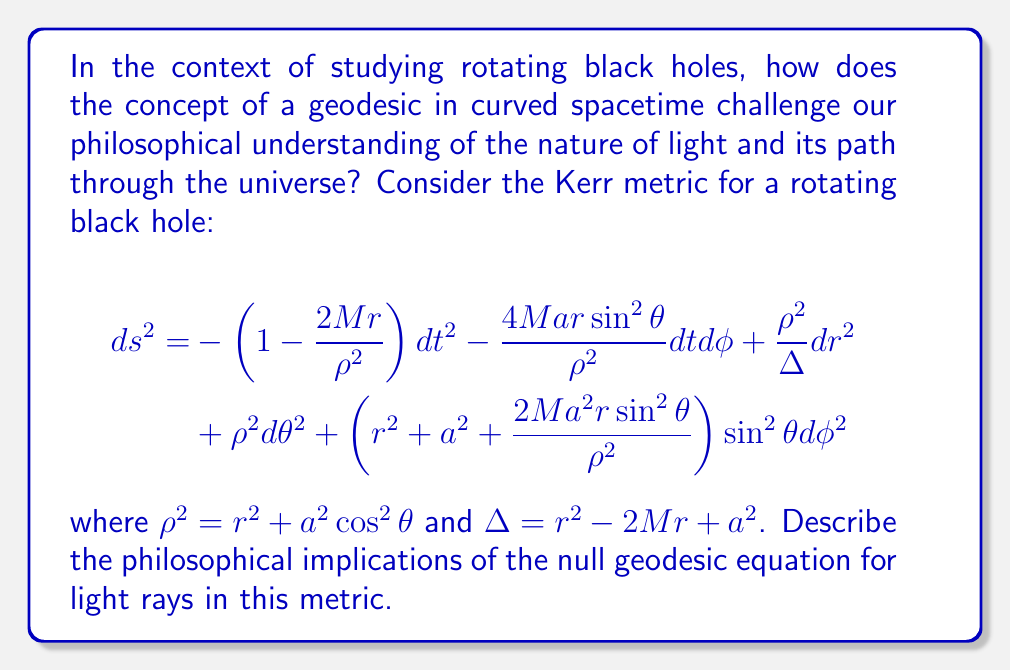Could you help me with this problem? To understand the philosophical implications of geodesics in curved spacetime around a rotating black hole, we need to examine the null geodesic equation in the Kerr metric:

1. The null geodesic equation is derived from the Lagrangian:
   $$\mathcal{L} = \frac{1}{2}g_{\mu\nu}\frac{dx^\mu}{d\lambda}\frac{dx^\nu}{d\lambda}$$
   where $\lambda$ is an affine parameter.

2. For light rays, we set $ds^2 = 0$ in the Kerr metric, as light follows null geodesics.

3. The geodesic equations are obtained using the Euler-Lagrange equations:
   $$\frac{d}{d\lambda}\left(\frac{\partial \mathcal{L}}{\partial \dot{x}^\mu}\right) - \frac{\partial \mathcal{L}}{\partial x^\mu} = 0$$

4. Due to the symmetries in the Kerr metric, we have two conserved quantities:
   - Energy: $E = -p_t = -g_{tt}\dot{t} - g_{t\phi}\dot{\phi}$
   - Angular momentum: $L = p_\phi = g_{\phi t}\dot{t} + g_{\phi\phi}\dot{\phi}$

5. The radial equation of motion can be written as:
   $$\left(\frac{dr}{d\lambda}\right)^2 = R(r)$$
   where $R(r)$ is a polynomial in $r$ that depends on $E$, $L$, and the black hole parameters.

6. The angular equation of motion is:
   $$\left(\frac{d\theta}{d\lambda}\right)^2 = \Theta(\theta)$$
   where $\Theta(\theta)$ is a function of $\theta$, $E$, $L$, and the black hole parameters.

Philosophical implications:

1. Determinism vs. Free Will: The geodesic equations suggest that light rays follow predetermined paths in curved spacetime, challenging our notion of free will in the universe.

2. Nature of Reality: The bending of light in curved spacetime implies that our perception of straight lines and Euclidean geometry is an approximation of a more complex underlying reality.

3. Limits of Knowledge: The existence of event horizons and ergospheres in rotating black holes suggests fundamental limits to our ability to observe and understand the universe.

4. Time and Causality: The dragging of inertial frames by rotating black holes challenges our classical understanding of time and causality.

5. Unity of Space and Time: The interdependence of spatial and temporal components in the geodesic equations reinforces the philosophical concept of spacetime as a unified entity.

6. Relationalism vs. Substantivalism: The geodesic equations support a relational view of spacetime, where the properties of space and time emerge from the relationships between events and objects.

These philosophical implications challenge our intuitive understanding of the universe and highlight the profound impact of studying black holes on our conceptual framework of reality.
Answer: Geodesics in curved spacetime around rotating black holes challenge our philosophical understanding of determinism, the nature of reality, limits of knowledge, time and causality, the unity of space and time, and the debate between relationalism and substantivalism in spacetime theories. 